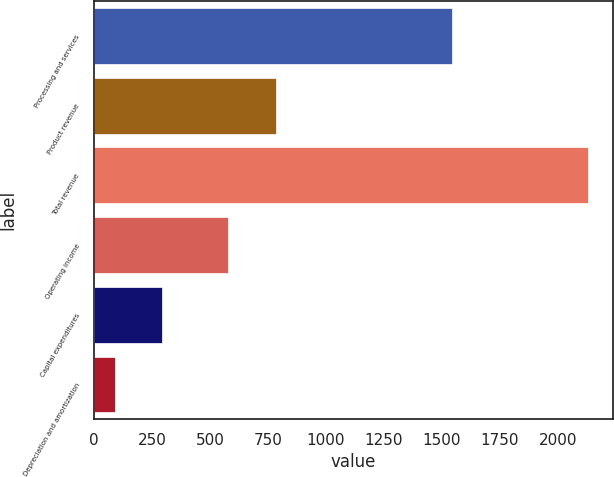<chart> <loc_0><loc_0><loc_500><loc_500><bar_chart><fcel>Processing and services<fcel>Product revenue<fcel>Total revenue<fcel>Operating income<fcel>Capital expenditures<fcel>Depreciation and amortization<nl><fcel>1542<fcel>783.3<fcel>2131<fcel>579<fcel>292.3<fcel>88<nl></chart> 